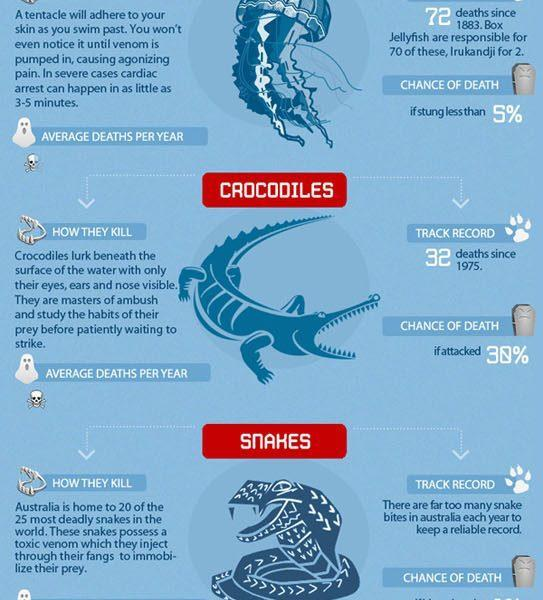How many creatures are shown in the images?
Answer the question with a short phrase. 3 How many deaths have been reported due to Box Jellyfish? 70 